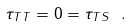Convert formula to latex. <formula><loc_0><loc_0><loc_500><loc_500>\tau _ { T T } = 0 = \tau _ { T S } \ .</formula> 